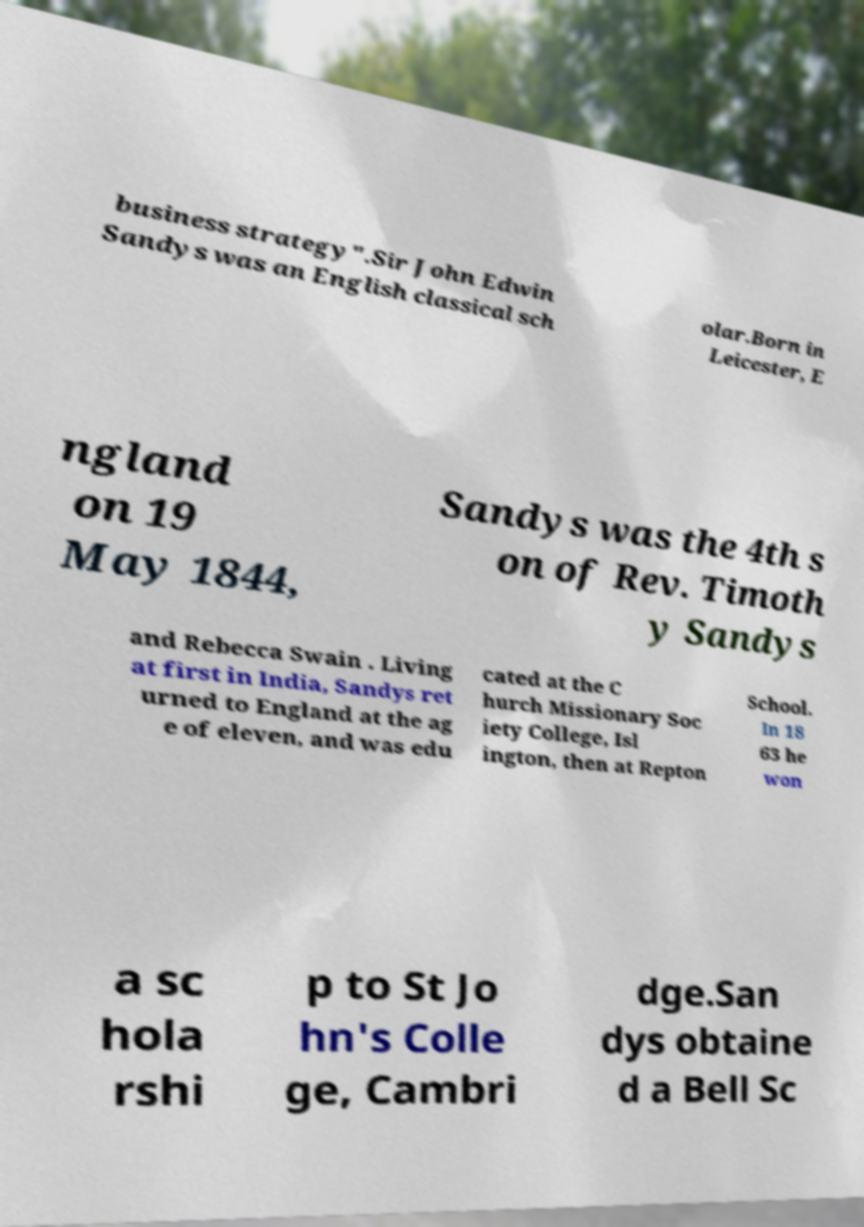Can you read and provide the text displayed in the image?This photo seems to have some interesting text. Can you extract and type it out for me? business strategy".Sir John Edwin Sandys was an English classical sch olar.Born in Leicester, E ngland on 19 May 1844, Sandys was the 4th s on of Rev. Timoth y Sandys and Rebecca Swain . Living at first in India, Sandys ret urned to England at the ag e of eleven, and was edu cated at the C hurch Missionary Soc iety College, Isl ington, then at Repton School. In 18 63 he won a sc hola rshi p to St Jo hn's Colle ge, Cambri dge.San dys obtaine d a Bell Sc 